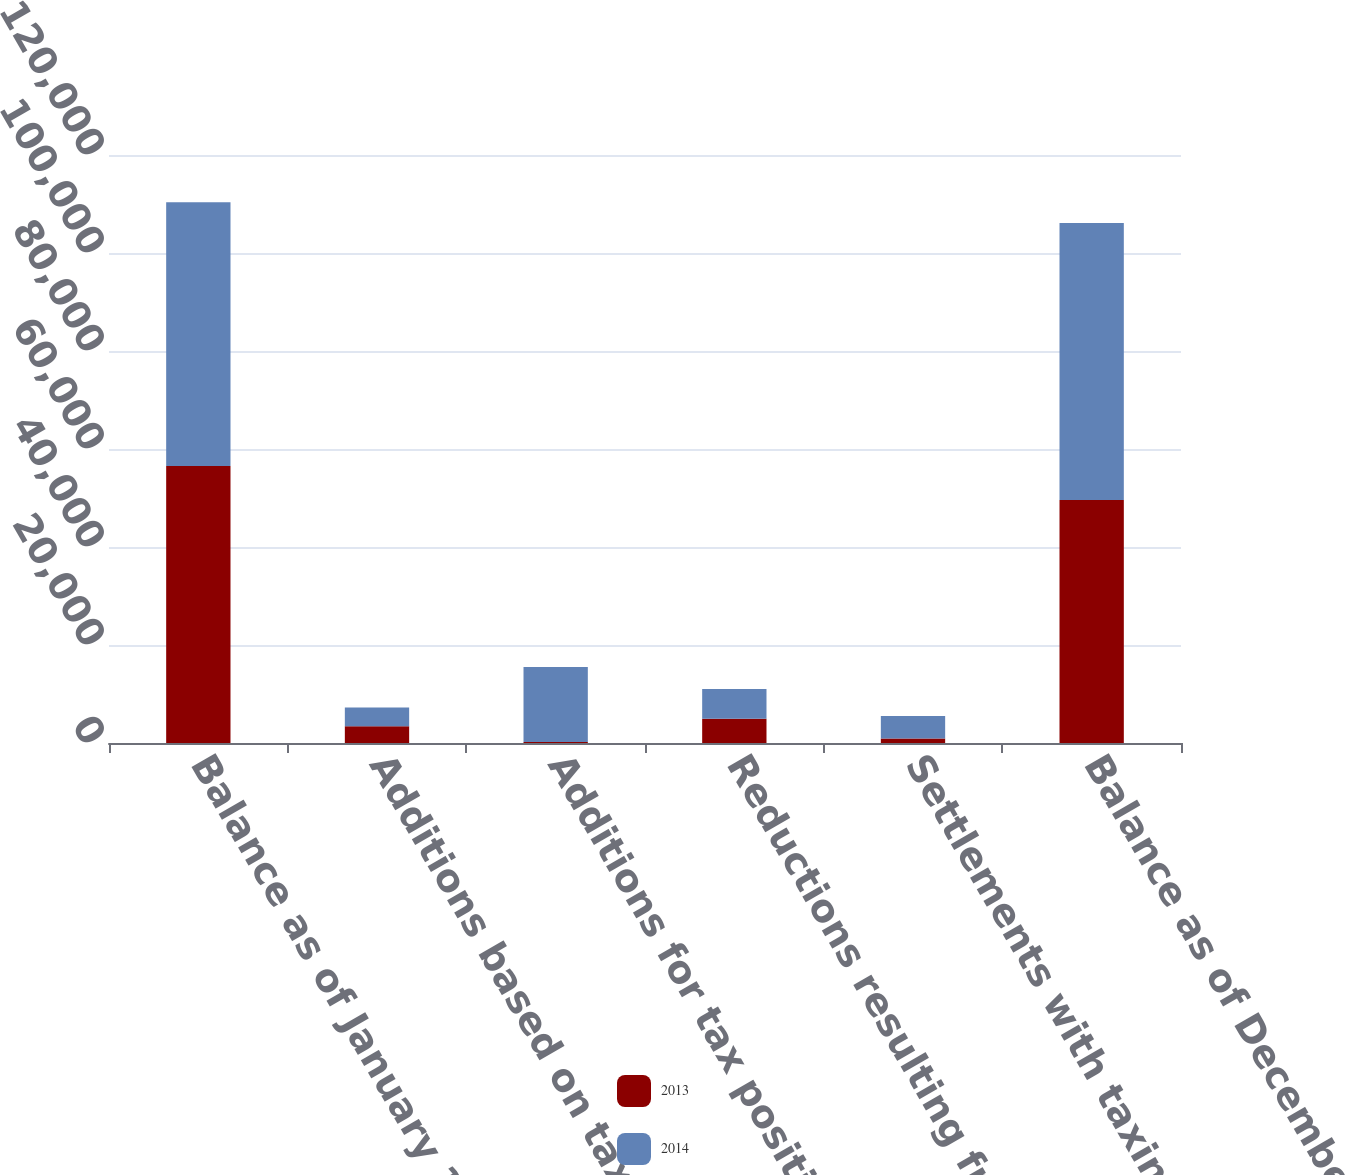Convert chart to OTSL. <chart><loc_0><loc_0><loc_500><loc_500><stacked_bar_chart><ecel><fcel>Balance as of January 1<fcel>Additions based on tax<fcel>Additions for tax positions of<fcel>Reductions resulting from the<fcel>Settlements with taxing<fcel>Balance as of December 31<nl><fcel>2013<fcel>56545<fcel>3424<fcel>219<fcel>4925<fcel>919<fcel>49599<nl><fcel>2014<fcel>53835<fcel>3840<fcel>15275<fcel>6075<fcel>4594<fcel>56545<nl></chart> 